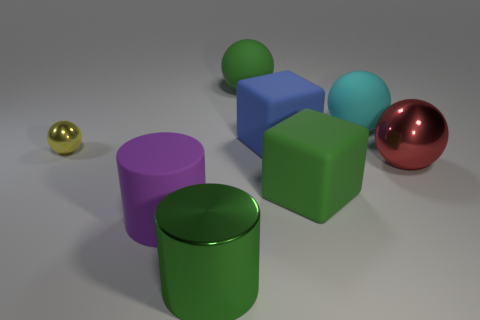Subtract all cyan matte balls. How many balls are left? 3 Add 1 green cylinders. How many objects exist? 9 Subtract all green balls. How many balls are left? 3 Subtract all green balls. Subtract all red cylinders. How many balls are left? 3 Subtract all blocks. How many objects are left? 6 Subtract all matte cubes. Subtract all green metallic cylinders. How many objects are left? 5 Add 1 tiny spheres. How many tiny spheres are left? 2 Add 7 small cyan cylinders. How many small cyan cylinders exist? 7 Subtract 1 yellow balls. How many objects are left? 7 